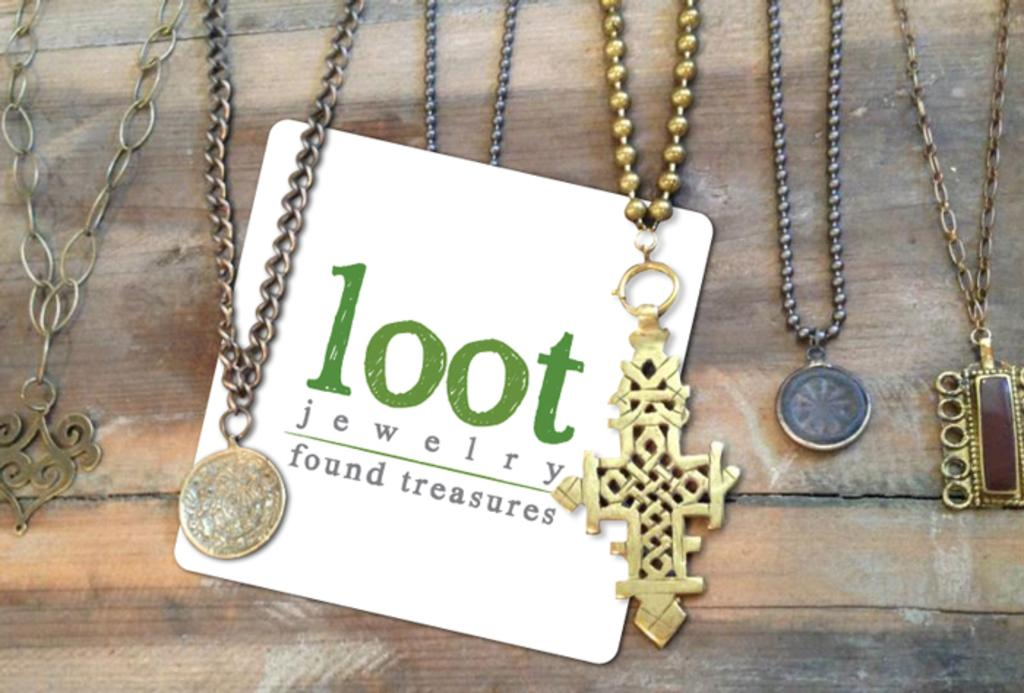What type of objects are connected by chains in the image? There are chains with lockets in the image. What is written or displayed on the board in the image? There is a board with text in the image. What material is the board made of? The board is made of wood. How many chairs are placed around the table in the image? There is no table or chairs present in the image. What type of sugar is used to sweeten the tea in the image? There is no tea or sugar present in the image. 